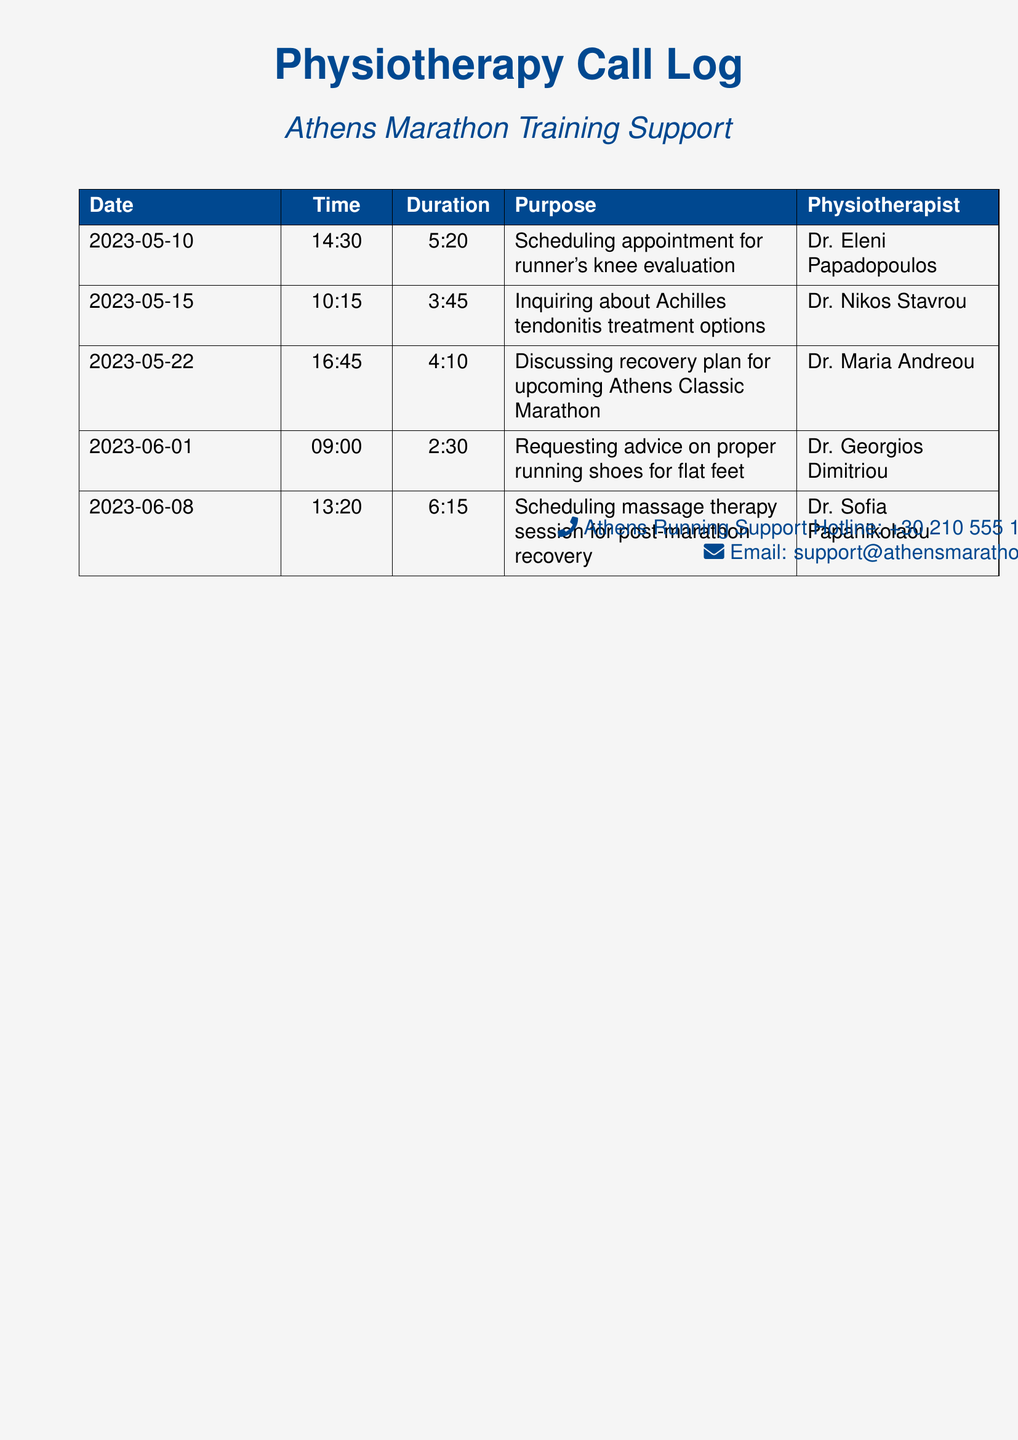What is the date of the first appointment? The first appointment recorded is on May 10, 2023.
Answer: May 10, 2023 Who is the physiotherapist for the conversation on June 1? The physiotherapist for the conversation on June 1 is mentioned in the log.
Answer: Dr. Georgios Dimitriou How long did the call on May 15 last? The duration of the call on May 15 is specified in the document.
Answer: 3:45 What is the purpose of the call on May 22? The purpose for the call on May 22 is detailed in the record.
Answer: Discussing recovery plan for upcoming Athens Classic Marathon Which physiotherapist specializes in Achilles tendonitis treatment options? This can be found in the log as part of the inquiry made on May 15.
Answer: Dr. Nikos Stavrou What time did the massage therapy session call occur? The time of the massage therapy session call can be found in the table.
Answer: 13:20 How many calls are about treatment options or evaluations? This requires counting the relevant entries in the log.
Answer: 3 What is the primary focus of the calls listed in the log? The primary focus is evident from the purpose of the calls recorded.
Answer: Runner's injuries and recovery What was inquired about during the call on June 1? The inquiry made on June 1 is clearly recorded in the document.
Answer: Proper running shoes for flat feet 